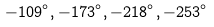Convert formula to latex. <formula><loc_0><loc_0><loc_500><loc_500>- 1 0 9 ^ { \circ } , - 1 7 3 ^ { \circ } , - 2 1 8 ^ { \circ } , - 2 5 3 ^ { \circ }</formula> 